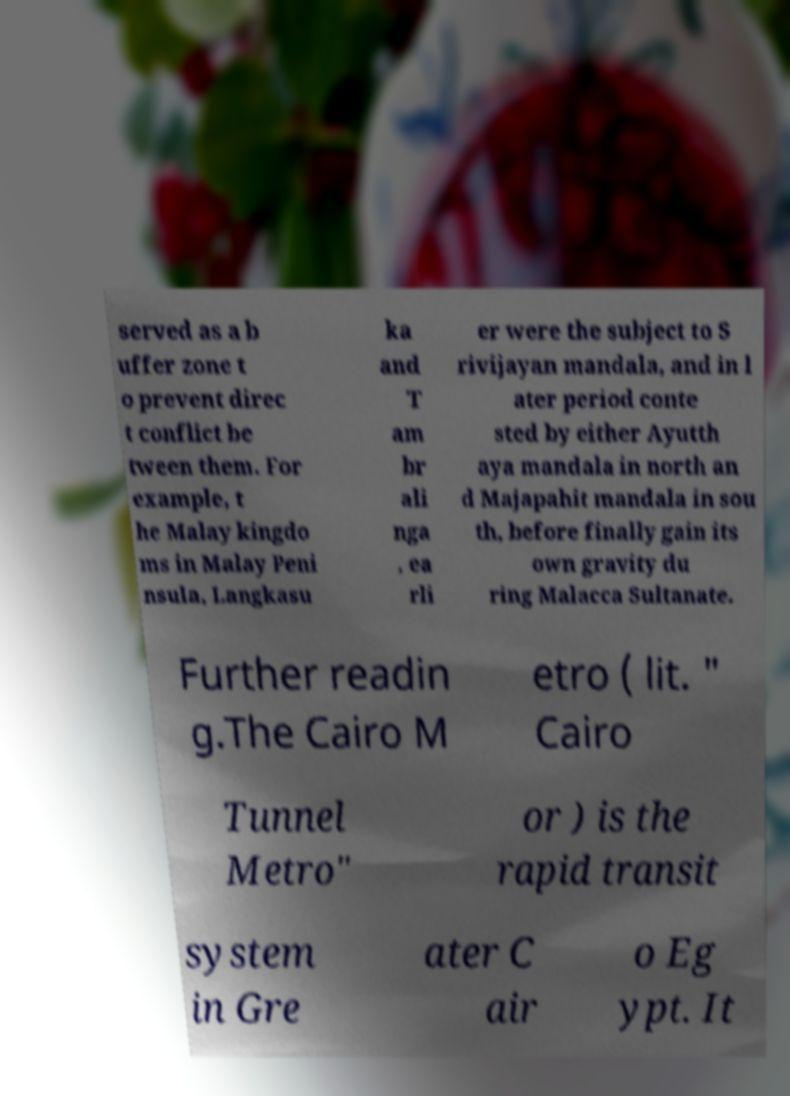Can you accurately transcribe the text from the provided image for me? served as a b uffer zone t o prevent direc t conflict be tween them. For example, t he Malay kingdo ms in Malay Peni nsula, Langkasu ka and T am br ali nga , ea rli er were the subject to S rivijayan mandala, and in l ater period conte sted by either Ayutth aya mandala in north an d Majapahit mandala in sou th, before finally gain its own gravity du ring Malacca Sultanate. Further readin g.The Cairo M etro ( lit. " Cairo Tunnel Metro" or ) is the rapid transit system in Gre ater C air o Eg ypt. It 